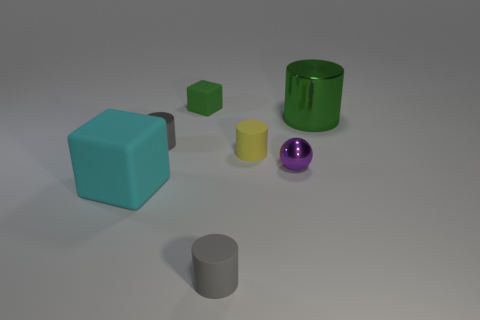Subtract all big metal cylinders. How many cylinders are left? 3 Subtract all green cylinders. How many cylinders are left? 3 Add 3 small green rubber cubes. How many objects exist? 10 Subtract all blocks. How many objects are left? 5 Subtract all purple cylinders. How many red balls are left? 0 Subtract all green rubber spheres. Subtract all green cylinders. How many objects are left? 6 Add 5 big metal things. How many big metal things are left? 6 Add 4 cyan spheres. How many cyan spheres exist? 4 Subtract 1 yellow cylinders. How many objects are left? 6 Subtract 1 blocks. How many blocks are left? 1 